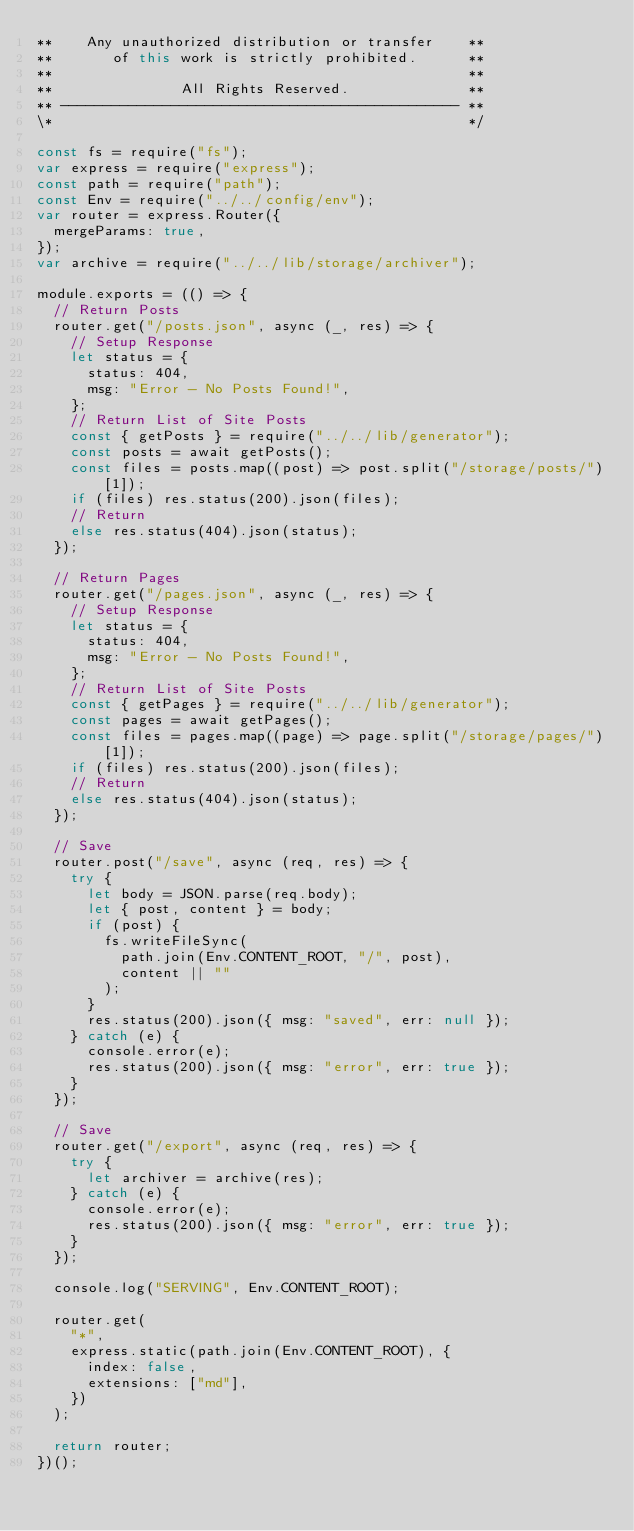Convert code to text. <code><loc_0><loc_0><loc_500><loc_500><_JavaScript_>**    Any unauthorized distribution or transfer    **
**       of this work is strictly prohibited.      **
**                                                 **
**               All Rights Reserved.              **
** ----------------------------------------------- **
\*                                                 */

const fs = require("fs");
var express = require("express");
const path = require("path");
const Env = require("../../config/env");
var router = express.Router({
  mergeParams: true,
});
var archive = require("../../lib/storage/archiver");

module.exports = (() => {
  // Return Posts
  router.get("/posts.json", async (_, res) => {
    // Setup Response
    let status = {
      status: 404,
      msg: "Error - No Posts Found!",
    };
    // Return List of Site Posts
    const { getPosts } = require("../../lib/generator");
    const posts = await getPosts();
    const files = posts.map((post) => post.split("/storage/posts/")[1]);
    if (files) res.status(200).json(files);
    // Return
    else res.status(404).json(status);
  });

  // Return Pages
  router.get("/pages.json", async (_, res) => {
    // Setup Response
    let status = {
      status: 404,
      msg: "Error - No Posts Found!",
    };
    // Return List of Site Posts
    const { getPages } = require("../../lib/generator");
    const pages = await getPages();
    const files = pages.map((page) => page.split("/storage/pages/")[1]);
    if (files) res.status(200).json(files);
    // Return
    else res.status(404).json(status);
  });

  // Save
  router.post("/save", async (req, res) => {
    try {
      let body = JSON.parse(req.body);
      let { post, content } = body;
      if (post) {
        fs.writeFileSync(
          path.join(Env.CONTENT_ROOT, "/", post),
          content || ""
        );
      }
      res.status(200).json({ msg: "saved", err: null });
    } catch (e) {
      console.error(e);
      res.status(200).json({ msg: "error", err: true });
    }
  });

  // Save
  router.get("/export", async (req, res) => {
    try {
      let archiver = archive(res);
    } catch (e) {
      console.error(e);
      res.status(200).json({ msg: "error", err: true });
    }
  });

  console.log("SERVING", Env.CONTENT_ROOT);

  router.get(
    "*",
    express.static(path.join(Env.CONTENT_ROOT), {
      index: false,
      extensions: ["md"],
    })
  );

  return router;
})();
</code> 